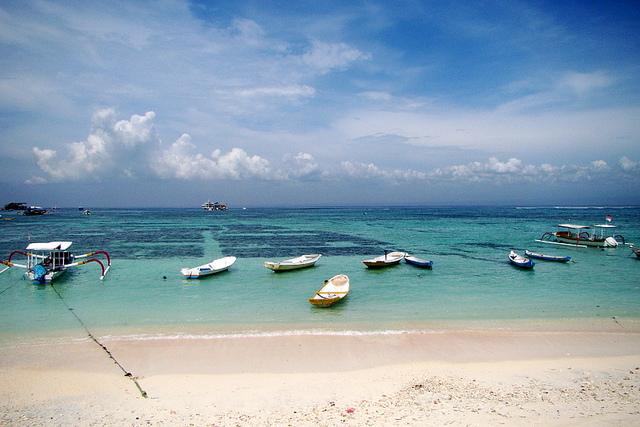Is there a commercial passenger boat in the photo?
Write a very short answer. No. Are all of the boats the same type?
Write a very short answer. No. How many boats are in the water?
Be succinct. 9. 